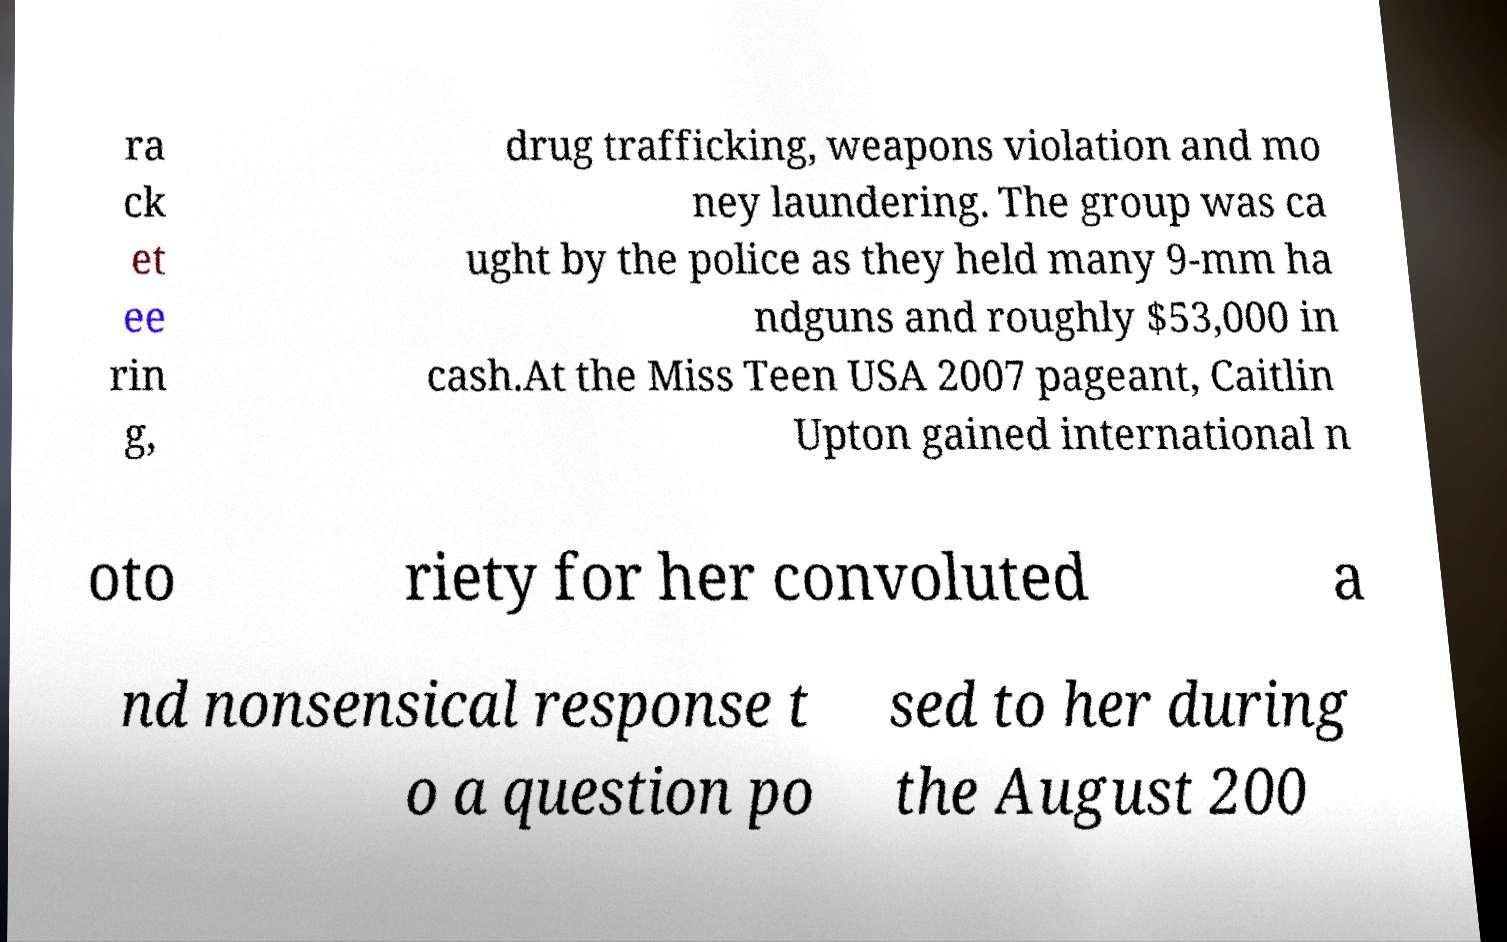Can you accurately transcribe the text from the provided image for me? ra ck et ee rin g, drug trafficking, weapons violation and mo ney laundering. The group was ca ught by the police as they held many 9-mm ha ndguns and roughly $53,000 in cash.At the Miss Teen USA 2007 pageant, Caitlin Upton gained international n oto riety for her convoluted a nd nonsensical response t o a question po sed to her during the August 200 